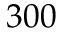<formula> <loc_0><loc_0><loc_500><loc_500>3 0 0</formula> 